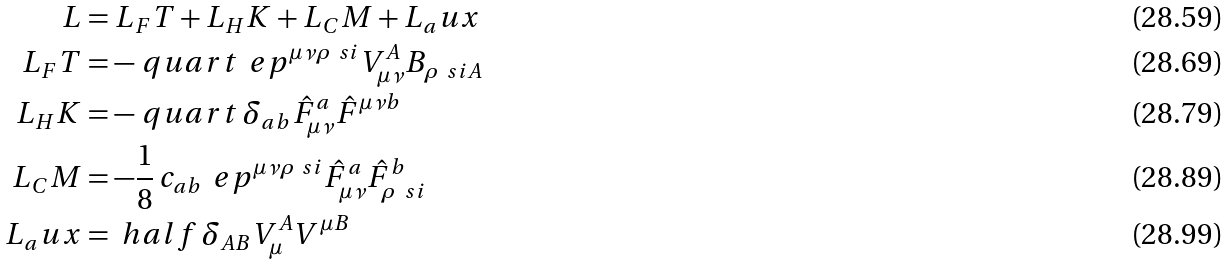Convert formula to latex. <formula><loc_0><loc_0><loc_500><loc_500>L & = L _ { F } T + L _ { H } K + L _ { C } M + L _ { a } u x \\ L _ { F } T & = - \ q u a r t \, \ e p ^ { \mu \nu \rho \ s i } V _ { \mu \nu } ^ { A } B _ { \rho \ s i A } \\ L _ { H } K & = - \ q u a r t \, \delta _ { a b } \hat { F } _ { \mu \nu } ^ { a } \hat { F } ^ { \mu \nu b } \\ L _ { C } M & = - \frac { 1 } { 8 } \, c _ { a b } \, \ e p ^ { \mu \nu \rho \ s i } \hat { F } _ { \mu \nu } ^ { a } \hat { F } _ { \rho \ s i } ^ { b } \\ L _ { a } u x & = \ h a l f \, \delta _ { A B } V _ { \mu } ^ { A } V ^ { \mu B }</formula> 